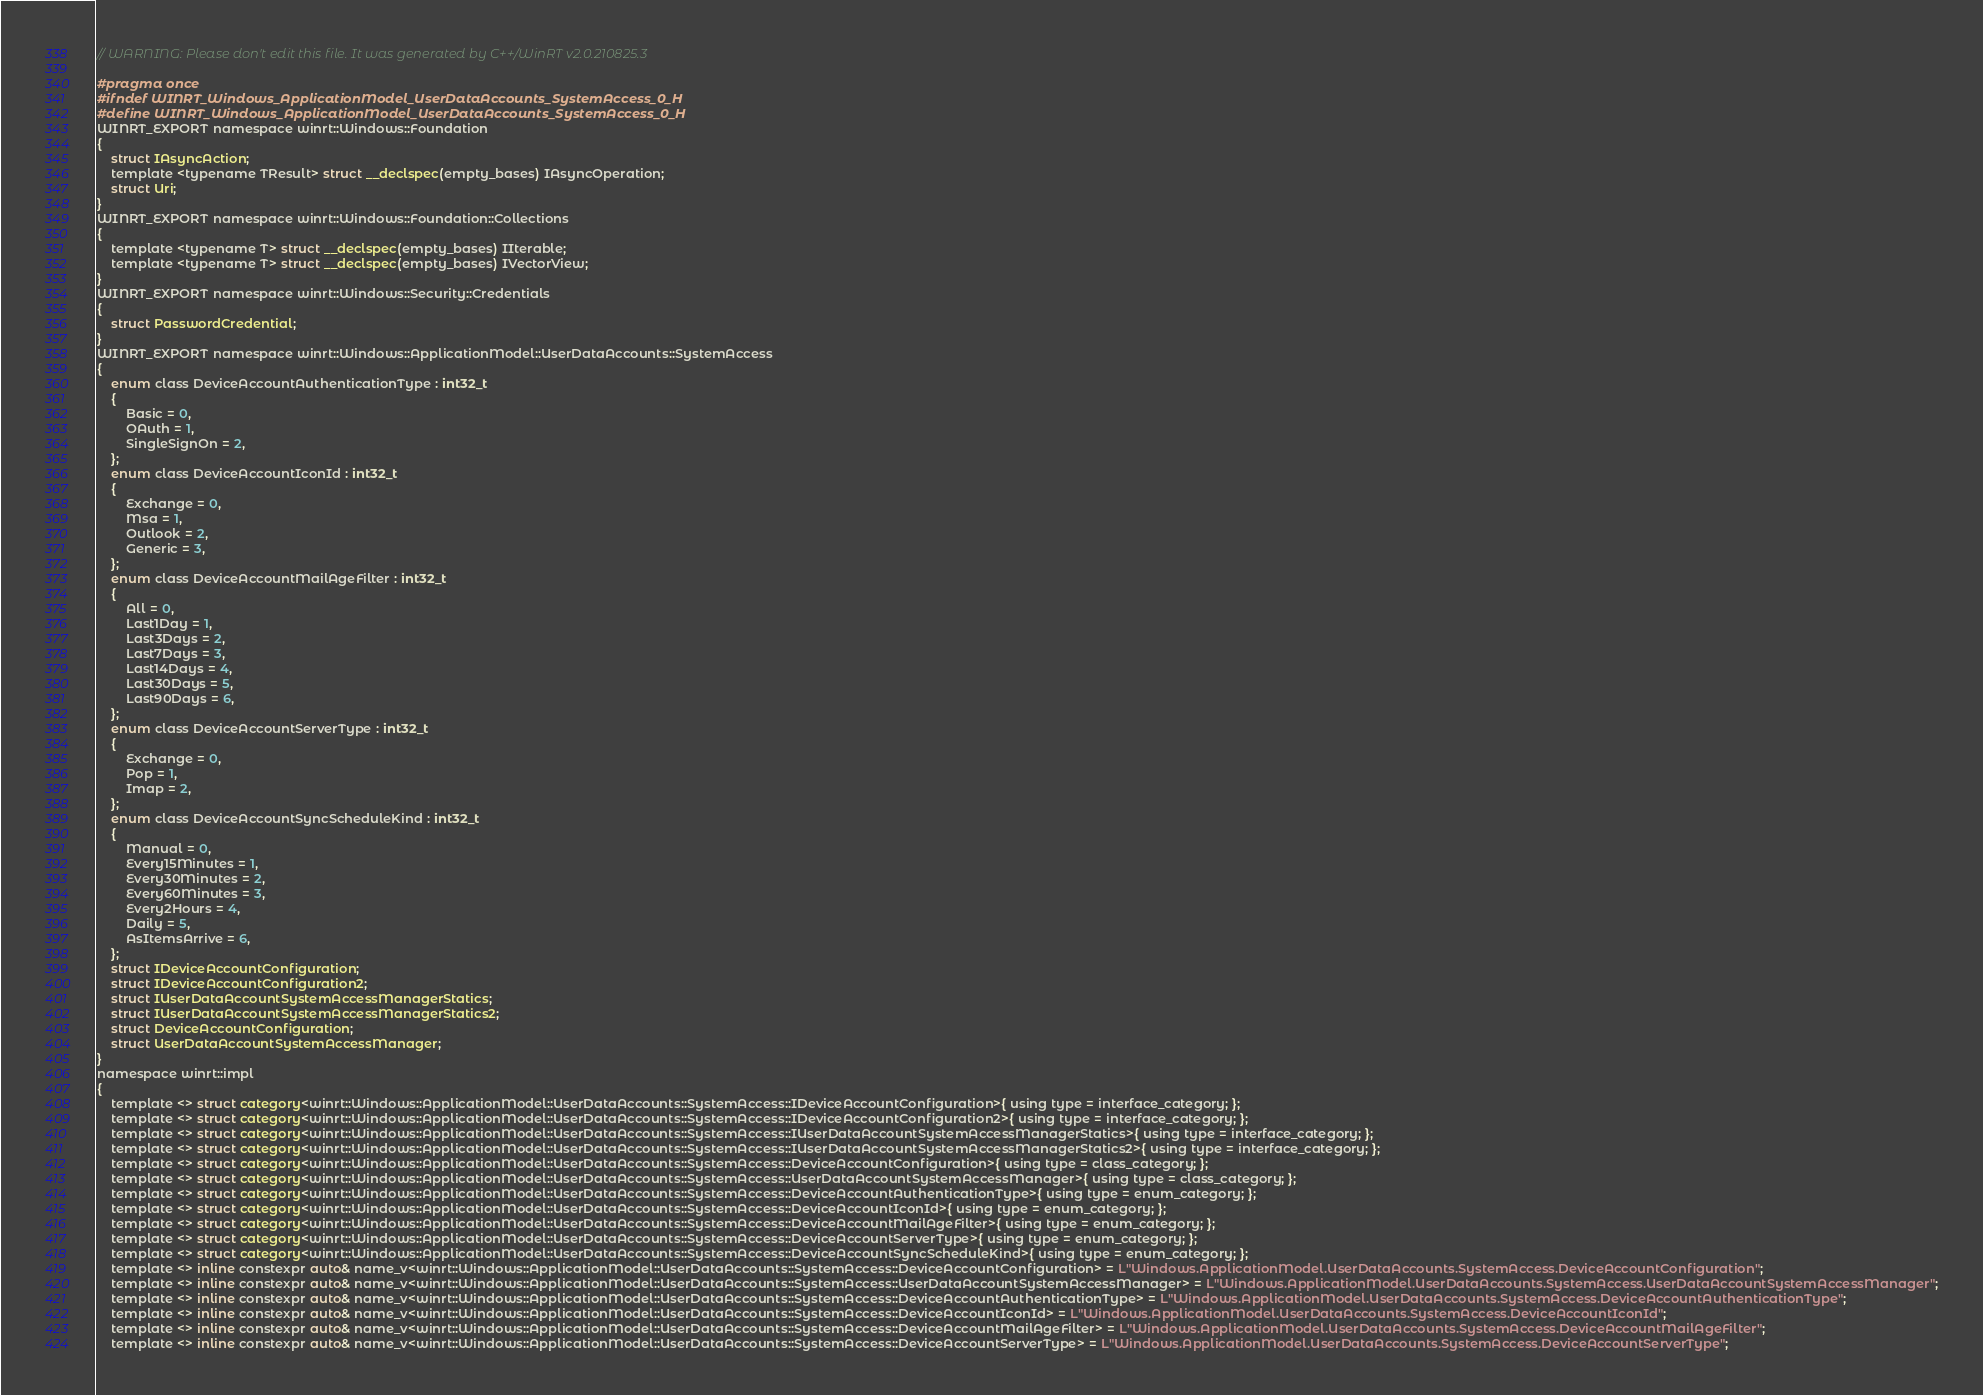<code> <loc_0><loc_0><loc_500><loc_500><_C_>// WARNING: Please don't edit this file. It was generated by C++/WinRT v2.0.210825.3

#pragma once
#ifndef WINRT_Windows_ApplicationModel_UserDataAccounts_SystemAccess_0_H
#define WINRT_Windows_ApplicationModel_UserDataAccounts_SystemAccess_0_H
WINRT_EXPORT namespace winrt::Windows::Foundation
{
    struct IAsyncAction;
    template <typename TResult> struct __declspec(empty_bases) IAsyncOperation;
    struct Uri;
}
WINRT_EXPORT namespace winrt::Windows::Foundation::Collections
{
    template <typename T> struct __declspec(empty_bases) IIterable;
    template <typename T> struct __declspec(empty_bases) IVectorView;
}
WINRT_EXPORT namespace winrt::Windows::Security::Credentials
{
    struct PasswordCredential;
}
WINRT_EXPORT namespace winrt::Windows::ApplicationModel::UserDataAccounts::SystemAccess
{
    enum class DeviceAccountAuthenticationType : int32_t
    {
        Basic = 0,
        OAuth = 1,
        SingleSignOn = 2,
    };
    enum class DeviceAccountIconId : int32_t
    {
        Exchange = 0,
        Msa = 1,
        Outlook = 2,
        Generic = 3,
    };
    enum class DeviceAccountMailAgeFilter : int32_t
    {
        All = 0,
        Last1Day = 1,
        Last3Days = 2,
        Last7Days = 3,
        Last14Days = 4,
        Last30Days = 5,
        Last90Days = 6,
    };
    enum class DeviceAccountServerType : int32_t
    {
        Exchange = 0,
        Pop = 1,
        Imap = 2,
    };
    enum class DeviceAccountSyncScheduleKind : int32_t
    {
        Manual = 0,
        Every15Minutes = 1,
        Every30Minutes = 2,
        Every60Minutes = 3,
        Every2Hours = 4,
        Daily = 5,
        AsItemsArrive = 6,
    };
    struct IDeviceAccountConfiguration;
    struct IDeviceAccountConfiguration2;
    struct IUserDataAccountSystemAccessManagerStatics;
    struct IUserDataAccountSystemAccessManagerStatics2;
    struct DeviceAccountConfiguration;
    struct UserDataAccountSystemAccessManager;
}
namespace winrt::impl
{
    template <> struct category<winrt::Windows::ApplicationModel::UserDataAccounts::SystemAccess::IDeviceAccountConfiguration>{ using type = interface_category; };
    template <> struct category<winrt::Windows::ApplicationModel::UserDataAccounts::SystemAccess::IDeviceAccountConfiguration2>{ using type = interface_category; };
    template <> struct category<winrt::Windows::ApplicationModel::UserDataAccounts::SystemAccess::IUserDataAccountSystemAccessManagerStatics>{ using type = interface_category; };
    template <> struct category<winrt::Windows::ApplicationModel::UserDataAccounts::SystemAccess::IUserDataAccountSystemAccessManagerStatics2>{ using type = interface_category; };
    template <> struct category<winrt::Windows::ApplicationModel::UserDataAccounts::SystemAccess::DeviceAccountConfiguration>{ using type = class_category; };
    template <> struct category<winrt::Windows::ApplicationModel::UserDataAccounts::SystemAccess::UserDataAccountSystemAccessManager>{ using type = class_category; };
    template <> struct category<winrt::Windows::ApplicationModel::UserDataAccounts::SystemAccess::DeviceAccountAuthenticationType>{ using type = enum_category; };
    template <> struct category<winrt::Windows::ApplicationModel::UserDataAccounts::SystemAccess::DeviceAccountIconId>{ using type = enum_category; };
    template <> struct category<winrt::Windows::ApplicationModel::UserDataAccounts::SystemAccess::DeviceAccountMailAgeFilter>{ using type = enum_category; };
    template <> struct category<winrt::Windows::ApplicationModel::UserDataAccounts::SystemAccess::DeviceAccountServerType>{ using type = enum_category; };
    template <> struct category<winrt::Windows::ApplicationModel::UserDataAccounts::SystemAccess::DeviceAccountSyncScheduleKind>{ using type = enum_category; };
    template <> inline constexpr auto& name_v<winrt::Windows::ApplicationModel::UserDataAccounts::SystemAccess::DeviceAccountConfiguration> = L"Windows.ApplicationModel.UserDataAccounts.SystemAccess.DeviceAccountConfiguration";
    template <> inline constexpr auto& name_v<winrt::Windows::ApplicationModel::UserDataAccounts::SystemAccess::UserDataAccountSystemAccessManager> = L"Windows.ApplicationModel.UserDataAccounts.SystemAccess.UserDataAccountSystemAccessManager";
    template <> inline constexpr auto& name_v<winrt::Windows::ApplicationModel::UserDataAccounts::SystemAccess::DeviceAccountAuthenticationType> = L"Windows.ApplicationModel.UserDataAccounts.SystemAccess.DeviceAccountAuthenticationType";
    template <> inline constexpr auto& name_v<winrt::Windows::ApplicationModel::UserDataAccounts::SystemAccess::DeviceAccountIconId> = L"Windows.ApplicationModel.UserDataAccounts.SystemAccess.DeviceAccountIconId";
    template <> inline constexpr auto& name_v<winrt::Windows::ApplicationModel::UserDataAccounts::SystemAccess::DeviceAccountMailAgeFilter> = L"Windows.ApplicationModel.UserDataAccounts.SystemAccess.DeviceAccountMailAgeFilter";
    template <> inline constexpr auto& name_v<winrt::Windows::ApplicationModel::UserDataAccounts::SystemAccess::DeviceAccountServerType> = L"Windows.ApplicationModel.UserDataAccounts.SystemAccess.DeviceAccountServerType";</code> 